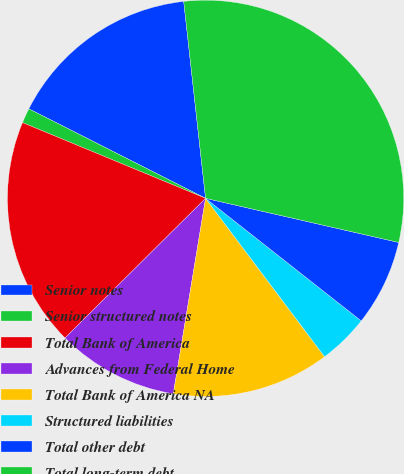Convert chart. <chart><loc_0><loc_0><loc_500><loc_500><pie_chart><fcel>Senior notes<fcel>Senior structured notes<fcel>Total Bank of America<fcel>Advances from Federal Home<fcel>Total Bank of America NA<fcel>Structured liabilities<fcel>Total other debt<fcel>Total long-term debt<nl><fcel>15.78%<fcel>1.22%<fcel>18.69%<fcel>9.95%<fcel>12.86%<fcel>4.13%<fcel>7.04%<fcel>30.34%<nl></chart> 